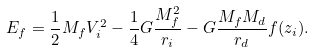<formula> <loc_0><loc_0><loc_500><loc_500>E _ { f } = \frac { 1 } { 2 } M _ { f } V _ { i } ^ { 2 } - \frac { 1 } { 4 } G \frac { M _ { f } ^ { 2 } } { r _ { i } } - G \frac { M _ { f } M _ { d } } { r _ { d } } f ( z _ { i } ) .</formula> 